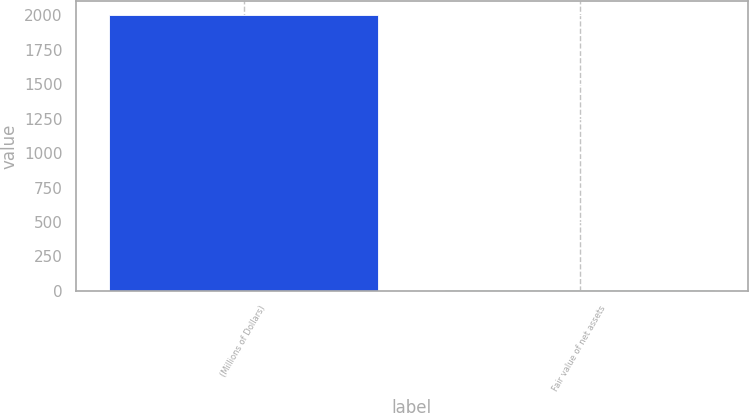Convert chart. <chart><loc_0><loc_0><loc_500><loc_500><bar_chart><fcel>(Millions of Dollars)<fcel>Fair value of net assets<nl><fcel>2003<fcel>5<nl></chart> 